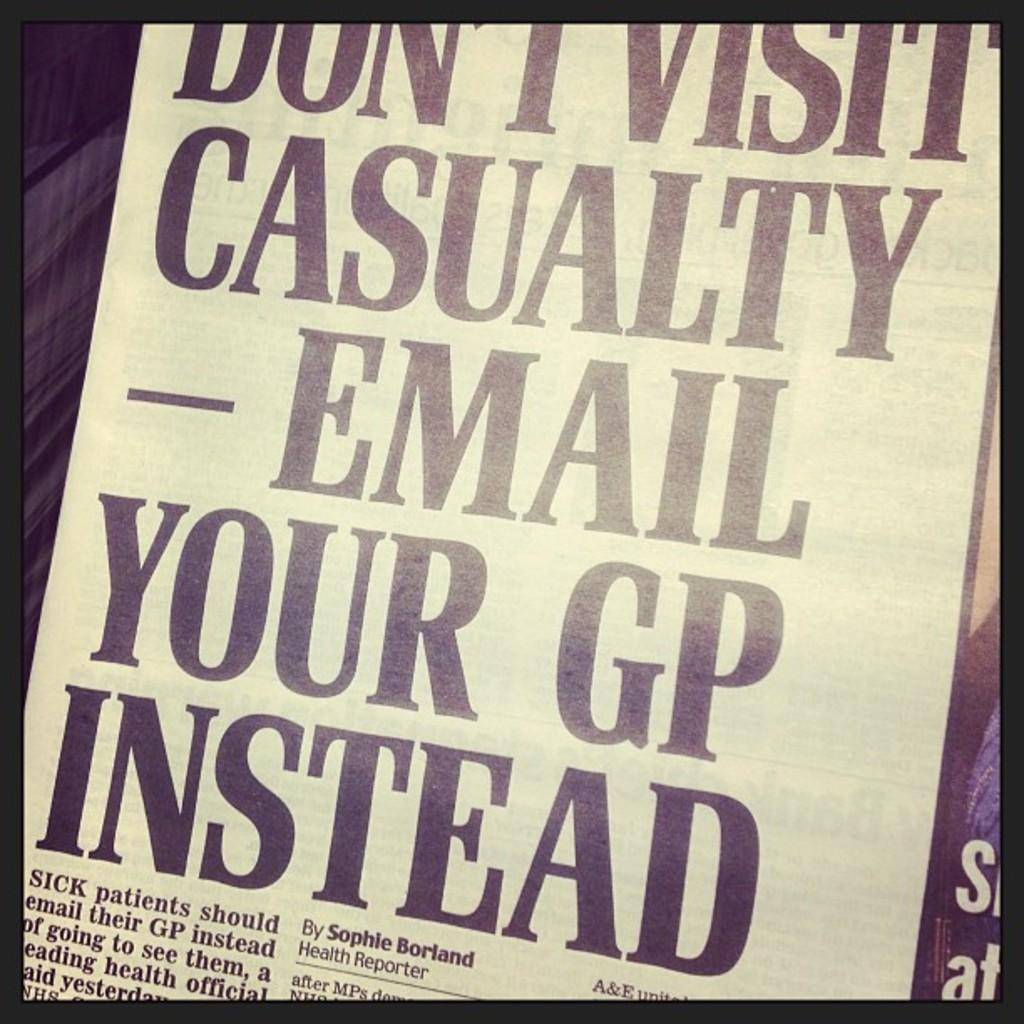<image>
Share a concise interpretation of the image provided. Paper that says "Don't visit casualty email your GP instead". 